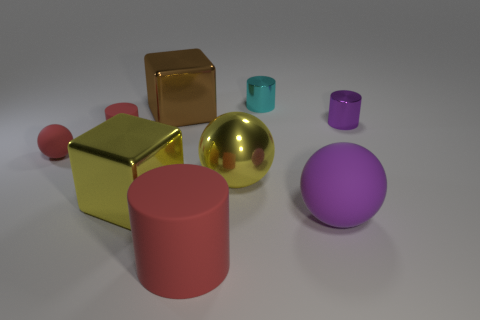Is the number of red rubber cylinders that are in front of the large yellow cube the same as the number of yellow blocks?
Offer a terse response. Yes. How many other things are the same shape as the cyan metal thing?
Your response must be concise. 3. The tiny cyan shiny thing is what shape?
Make the answer very short. Cylinder. Does the small red cylinder have the same material as the red ball?
Offer a very short reply. Yes. Are there the same number of yellow things on the left side of the big brown shiny cube and cylinders in front of the large purple thing?
Ensure brevity in your answer.  Yes. Is there a purple rubber ball to the right of the object that is left of the red rubber cylinder behind the large red rubber thing?
Offer a terse response. Yes. Does the cyan shiny cylinder have the same size as the yellow sphere?
Make the answer very short. No. What is the color of the big matte object right of the cylinder that is behind the small metallic object that is to the right of the tiny cyan metal cylinder?
Keep it short and to the point. Purple. What number of large cubes have the same color as the small rubber cylinder?
Keep it short and to the point. 0. What number of big objects are metal blocks or green matte spheres?
Provide a succinct answer. 2. 